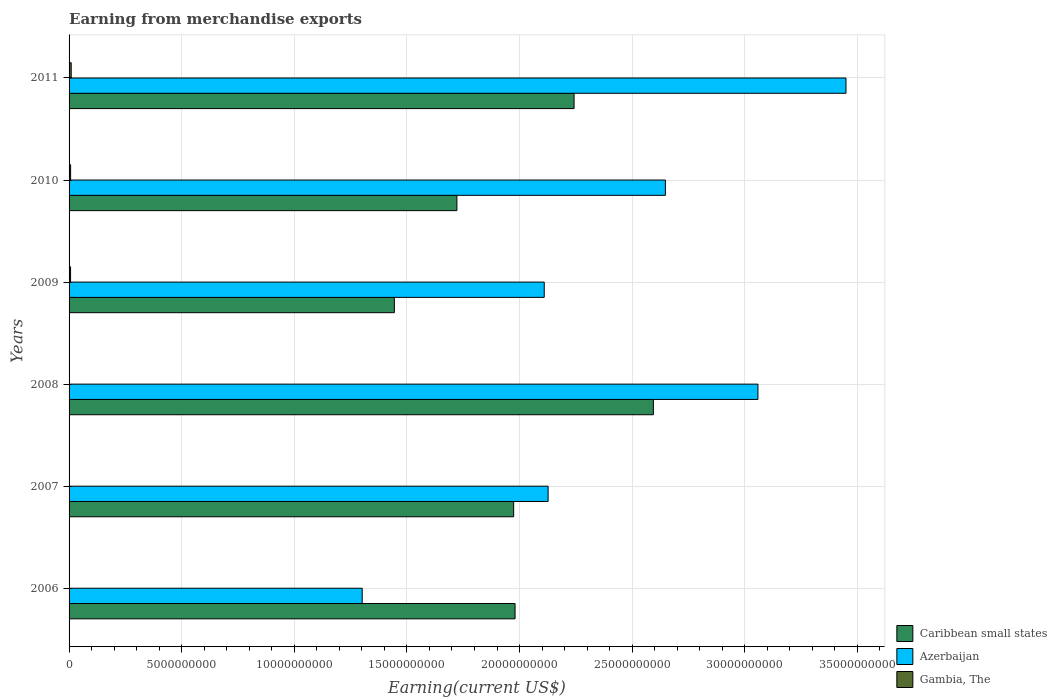How many different coloured bars are there?
Provide a succinct answer. 3. How many groups of bars are there?
Offer a terse response. 6. Are the number of bars on each tick of the Y-axis equal?
Provide a short and direct response. Yes. What is the amount earned from merchandise exports in Azerbaijan in 2010?
Offer a very short reply. 2.65e+1. Across all years, what is the maximum amount earned from merchandise exports in Gambia, The?
Provide a succinct answer. 9.49e+07. Across all years, what is the minimum amount earned from merchandise exports in Azerbaijan?
Offer a terse response. 1.30e+1. In which year was the amount earned from merchandise exports in Caribbean small states maximum?
Provide a short and direct response. 2008. What is the total amount earned from merchandise exports in Caribbean small states in the graph?
Keep it short and to the point. 1.20e+11. What is the difference between the amount earned from merchandise exports in Caribbean small states in 2008 and that in 2009?
Your answer should be compact. 1.15e+1. What is the difference between the amount earned from merchandise exports in Azerbaijan in 2009 and the amount earned from merchandise exports in Caribbean small states in 2011?
Make the answer very short. -1.33e+09. What is the average amount earned from merchandise exports in Caribbean small states per year?
Your response must be concise. 1.99e+1. In the year 2006, what is the difference between the amount earned from merchandise exports in Caribbean small states and amount earned from merchandise exports in Gambia, The?
Give a very brief answer. 1.98e+1. In how many years, is the amount earned from merchandise exports in Azerbaijan greater than 33000000000 US$?
Offer a very short reply. 1. What is the ratio of the amount earned from merchandise exports in Gambia, The in 2007 to that in 2011?
Your answer should be very brief. 0.14. Is the amount earned from merchandise exports in Gambia, The in 2007 less than that in 2009?
Give a very brief answer. Yes. Is the difference between the amount earned from merchandise exports in Caribbean small states in 2009 and 2011 greater than the difference between the amount earned from merchandise exports in Gambia, The in 2009 and 2011?
Keep it short and to the point. No. What is the difference between the highest and the second highest amount earned from merchandise exports in Azerbaijan?
Give a very brief answer. 3.91e+09. What is the difference between the highest and the lowest amount earned from merchandise exports in Caribbean small states?
Your answer should be very brief. 1.15e+1. In how many years, is the amount earned from merchandise exports in Azerbaijan greater than the average amount earned from merchandise exports in Azerbaijan taken over all years?
Offer a very short reply. 3. What does the 2nd bar from the top in 2006 represents?
Provide a short and direct response. Azerbaijan. What does the 3rd bar from the bottom in 2006 represents?
Provide a succinct answer. Gambia, The. Is it the case that in every year, the sum of the amount earned from merchandise exports in Azerbaijan and amount earned from merchandise exports in Gambia, The is greater than the amount earned from merchandise exports in Caribbean small states?
Keep it short and to the point. No. How many bars are there?
Ensure brevity in your answer.  18. Are all the bars in the graph horizontal?
Your answer should be compact. Yes. How many years are there in the graph?
Offer a very short reply. 6. Does the graph contain grids?
Keep it short and to the point. Yes. How many legend labels are there?
Offer a terse response. 3. How are the legend labels stacked?
Your answer should be very brief. Vertical. What is the title of the graph?
Your answer should be compact. Earning from merchandise exports. What is the label or title of the X-axis?
Ensure brevity in your answer.  Earning(current US$). What is the label or title of the Y-axis?
Your response must be concise. Years. What is the Earning(current US$) of Caribbean small states in 2006?
Your answer should be very brief. 1.98e+1. What is the Earning(current US$) in Azerbaijan in 2006?
Offer a terse response. 1.30e+1. What is the Earning(current US$) in Gambia, The in 2006?
Provide a succinct answer. 1.15e+07. What is the Earning(current US$) of Caribbean small states in 2007?
Offer a very short reply. 1.97e+1. What is the Earning(current US$) in Azerbaijan in 2007?
Your answer should be very brief. 2.13e+1. What is the Earning(current US$) of Gambia, The in 2007?
Your response must be concise. 1.33e+07. What is the Earning(current US$) of Caribbean small states in 2008?
Provide a succinct answer. 2.59e+1. What is the Earning(current US$) in Azerbaijan in 2008?
Provide a short and direct response. 3.06e+1. What is the Earning(current US$) in Gambia, The in 2008?
Provide a short and direct response. 1.37e+07. What is the Earning(current US$) of Caribbean small states in 2009?
Provide a succinct answer. 1.44e+1. What is the Earning(current US$) of Azerbaijan in 2009?
Your answer should be compact. 2.11e+1. What is the Earning(current US$) of Gambia, The in 2009?
Keep it short and to the point. 6.59e+07. What is the Earning(current US$) of Caribbean small states in 2010?
Make the answer very short. 1.72e+1. What is the Earning(current US$) of Azerbaijan in 2010?
Make the answer very short. 2.65e+1. What is the Earning(current US$) in Gambia, The in 2010?
Keep it short and to the point. 6.83e+07. What is the Earning(current US$) of Caribbean small states in 2011?
Keep it short and to the point. 2.24e+1. What is the Earning(current US$) in Azerbaijan in 2011?
Ensure brevity in your answer.  3.45e+1. What is the Earning(current US$) of Gambia, The in 2011?
Provide a succinct answer. 9.49e+07. Across all years, what is the maximum Earning(current US$) of Caribbean small states?
Provide a short and direct response. 2.59e+1. Across all years, what is the maximum Earning(current US$) in Azerbaijan?
Offer a very short reply. 3.45e+1. Across all years, what is the maximum Earning(current US$) of Gambia, The?
Your response must be concise. 9.49e+07. Across all years, what is the minimum Earning(current US$) of Caribbean small states?
Keep it short and to the point. 1.44e+1. Across all years, what is the minimum Earning(current US$) of Azerbaijan?
Make the answer very short. 1.30e+1. Across all years, what is the minimum Earning(current US$) in Gambia, The?
Offer a terse response. 1.15e+07. What is the total Earning(current US$) of Caribbean small states in the graph?
Provide a short and direct response. 1.20e+11. What is the total Earning(current US$) of Azerbaijan in the graph?
Ensure brevity in your answer.  1.47e+11. What is the total Earning(current US$) in Gambia, The in the graph?
Provide a short and direct response. 2.68e+08. What is the difference between the Earning(current US$) in Caribbean small states in 2006 and that in 2007?
Give a very brief answer. 6.19e+07. What is the difference between the Earning(current US$) of Azerbaijan in 2006 and that in 2007?
Make the answer very short. -8.25e+09. What is the difference between the Earning(current US$) in Gambia, The in 2006 and that in 2007?
Offer a very short reply. -1.87e+06. What is the difference between the Earning(current US$) of Caribbean small states in 2006 and that in 2008?
Your answer should be very brief. -6.14e+09. What is the difference between the Earning(current US$) of Azerbaijan in 2006 and that in 2008?
Ensure brevity in your answer.  -1.76e+1. What is the difference between the Earning(current US$) of Gambia, The in 2006 and that in 2008?
Keep it short and to the point. -2.21e+06. What is the difference between the Earning(current US$) of Caribbean small states in 2006 and that in 2009?
Provide a short and direct response. 5.36e+09. What is the difference between the Earning(current US$) in Azerbaijan in 2006 and that in 2009?
Provide a short and direct response. -8.08e+09. What is the difference between the Earning(current US$) of Gambia, The in 2006 and that in 2009?
Keep it short and to the point. -5.45e+07. What is the difference between the Earning(current US$) of Caribbean small states in 2006 and that in 2010?
Provide a succinct answer. 2.58e+09. What is the difference between the Earning(current US$) of Azerbaijan in 2006 and that in 2010?
Give a very brief answer. -1.35e+1. What is the difference between the Earning(current US$) of Gambia, The in 2006 and that in 2010?
Your answer should be very brief. -5.68e+07. What is the difference between the Earning(current US$) in Caribbean small states in 2006 and that in 2011?
Offer a terse response. -2.62e+09. What is the difference between the Earning(current US$) in Azerbaijan in 2006 and that in 2011?
Make the answer very short. -2.15e+1. What is the difference between the Earning(current US$) in Gambia, The in 2006 and that in 2011?
Ensure brevity in your answer.  -8.34e+07. What is the difference between the Earning(current US$) in Caribbean small states in 2007 and that in 2008?
Ensure brevity in your answer.  -6.20e+09. What is the difference between the Earning(current US$) of Azerbaijan in 2007 and that in 2008?
Offer a very short reply. -9.32e+09. What is the difference between the Earning(current US$) in Gambia, The in 2007 and that in 2008?
Your answer should be very brief. -3.33e+05. What is the difference between the Earning(current US$) in Caribbean small states in 2007 and that in 2009?
Offer a very short reply. 5.30e+09. What is the difference between the Earning(current US$) in Azerbaijan in 2007 and that in 2009?
Provide a succinct answer. 1.72e+08. What is the difference between the Earning(current US$) of Gambia, The in 2007 and that in 2009?
Provide a short and direct response. -5.26e+07. What is the difference between the Earning(current US$) in Caribbean small states in 2007 and that in 2010?
Make the answer very short. 2.52e+09. What is the difference between the Earning(current US$) of Azerbaijan in 2007 and that in 2010?
Your answer should be compact. -5.21e+09. What is the difference between the Earning(current US$) in Gambia, The in 2007 and that in 2010?
Offer a terse response. -5.50e+07. What is the difference between the Earning(current US$) in Caribbean small states in 2007 and that in 2011?
Ensure brevity in your answer.  -2.68e+09. What is the difference between the Earning(current US$) of Azerbaijan in 2007 and that in 2011?
Make the answer very short. -1.32e+1. What is the difference between the Earning(current US$) in Gambia, The in 2007 and that in 2011?
Your response must be concise. -8.16e+07. What is the difference between the Earning(current US$) of Caribbean small states in 2008 and that in 2009?
Offer a very short reply. 1.15e+1. What is the difference between the Earning(current US$) of Azerbaijan in 2008 and that in 2009?
Provide a short and direct response. 9.49e+09. What is the difference between the Earning(current US$) in Gambia, The in 2008 and that in 2009?
Your answer should be compact. -5.22e+07. What is the difference between the Earning(current US$) of Caribbean small states in 2008 and that in 2010?
Your answer should be very brief. 8.72e+09. What is the difference between the Earning(current US$) in Azerbaijan in 2008 and that in 2010?
Your response must be concise. 4.11e+09. What is the difference between the Earning(current US$) of Gambia, The in 2008 and that in 2010?
Ensure brevity in your answer.  -5.46e+07. What is the difference between the Earning(current US$) of Caribbean small states in 2008 and that in 2011?
Provide a succinct answer. 3.52e+09. What is the difference between the Earning(current US$) in Azerbaijan in 2008 and that in 2011?
Your response must be concise. -3.91e+09. What is the difference between the Earning(current US$) in Gambia, The in 2008 and that in 2011?
Offer a very short reply. -8.12e+07. What is the difference between the Earning(current US$) in Caribbean small states in 2009 and that in 2010?
Offer a very short reply. -2.78e+09. What is the difference between the Earning(current US$) in Azerbaijan in 2009 and that in 2010?
Make the answer very short. -5.38e+09. What is the difference between the Earning(current US$) of Gambia, The in 2009 and that in 2010?
Offer a terse response. -2.37e+06. What is the difference between the Earning(current US$) of Caribbean small states in 2009 and that in 2011?
Your answer should be very brief. -7.98e+09. What is the difference between the Earning(current US$) of Azerbaijan in 2009 and that in 2011?
Your answer should be very brief. -1.34e+1. What is the difference between the Earning(current US$) in Gambia, The in 2009 and that in 2011?
Make the answer very short. -2.90e+07. What is the difference between the Earning(current US$) of Caribbean small states in 2010 and that in 2011?
Keep it short and to the point. -5.20e+09. What is the difference between the Earning(current US$) in Azerbaijan in 2010 and that in 2011?
Ensure brevity in your answer.  -8.02e+09. What is the difference between the Earning(current US$) of Gambia, The in 2010 and that in 2011?
Offer a terse response. -2.66e+07. What is the difference between the Earning(current US$) in Caribbean small states in 2006 and the Earning(current US$) in Azerbaijan in 2007?
Your answer should be very brief. -1.47e+09. What is the difference between the Earning(current US$) in Caribbean small states in 2006 and the Earning(current US$) in Gambia, The in 2007?
Your answer should be compact. 1.98e+1. What is the difference between the Earning(current US$) in Azerbaijan in 2006 and the Earning(current US$) in Gambia, The in 2007?
Your answer should be very brief. 1.30e+1. What is the difference between the Earning(current US$) of Caribbean small states in 2006 and the Earning(current US$) of Azerbaijan in 2008?
Offer a very short reply. -1.08e+1. What is the difference between the Earning(current US$) in Caribbean small states in 2006 and the Earning(current US$) in Gambia, The in 2008?
Offer a very short reply. 1.98e+1. What is the difference between the Earning(current US$) of Azerbaijan in 2006 and the Earning(current US$) of Gambia, The in 2008?
Give a very brief answer. 1.30e+1. What is the difference between the Earning(current US$) in Caribbean small states in 2006 and the Earning(current US$) in Azerbaijan in 2009?
Give a very brief answer. -1.30e+09. What is the difference between the Earning(current US$) in Caribbean small states in 2006 and the Earning(current US$) in Gambia, The in 2009?
Keep it short and to the point. 1.97e+1. What is the difference between the Earning(current US$) of Azerbaijan in 2006 and the Earning(current US$) of Gambia, The in 2009?
Offer a terse response. 1.29e+1. What is the difference between the Earning(current US$) in Caribbean small states in 2006 and the Earning(current US$) in Azerbaijan in 2010?
Your answer should be compact. -6.67e+09. What is the difference between the Earning(current US$) in Caribbean small states in 2006 and the Earning(current US$) in Gambia, The in 2010?
Provide a short and direct response. 1.97e+1. What is the difference between the Earning(current US$) of Azerbaijan in 2006 and the Earning(current US$) of Gambia, The in 2010?
Give a very brief answer. 1.29e+1. What is the difference between the Earning(current US$) in Caribbean small states in 2006 and the Earning(current US$) in Azerbaijan in 2011?
Your answer should be very brief. -1.47e+1. What is the difference between the Earning(current US$) of Caribbean small states in 2006 and the Earning(current US$) of Gambia, The in 2011?
Your response must be concise. 1.97e+1. What is the difference between the Earning(current US$) of Azerbaijan in 2006 and the Earning(current US$) of Gambia, The in 2011?
Your response must be concise. 1.29e+1. What is the difference between the Earning(current US$) of Caribbean small states in 2007 and the Earning(current US$) of Azerbaijan in 2008?
Your answer should be very brief. -1.08e+1. What is the difference between the Earning(current US$) of Caribbean small states in 2007 and the Earning(current US$) of Gambia, The in 2008?
Give a very brief answer. 1.97e+1. What is the difference between the Earning(current US$) of Azerbaijan in 2007 and the Earning(current US$) of Gambia, The in 2008?
Your response must be concise. 2.13e+1. What is the difference between the Earning(current US$) of Caribbean small states in 2007 and the Earning(current US$) of Azerbaijan in 2009?
Provide a succinct answer. -1.36e+09. What is the difference between the Earning(current US$) of Caribbean small states in 2007 and the Earning(current US$) of Gambia, The in 2009?
Your answer should be very brief. 1.97e+1. What is the difference between the Earning(current US$) in Azerbaijan in 2007 and the Earning(current US$) in Gambia, The in 2009?
Provide a short and direct response. 2.12e+1. What is the difference between the Earning(current US$) of Caribbean small states in 2007 and the Earning(current US$) of Azerbaijan in 2010?
Your answer should be compact. -6.74e+09. What is the difference between the Earning(current US$) in Caribbean small states in 2007 and the Earning(current US$) in Gambia, The in 2010?
Provide a succinct answer. 1.97e+1. What is the difference between the Earning(current US$) of Azerbaijan in 2007 and the Earning(current US$) of Gambia, The in 2010?
Make the answer very short. 2.12e+1. What is the difference between the Earning(current US$) of Caribbean small states in 2007 and the Earning(current US$) of Azerbaijan in 2011?
Your response must be concise. -1.48e+1. What is the difference between the Earning(current US$) of Caribbean small states in 2007 and the Earning(current US$) of Gambia, The in 2011?
Your response must be concise. 1.96e+1. What is the difference between the Earning(current US$) of Azerbaijan in 2007 and the Earning(current US$) of Gambia, The in 2011?
Make the answer very short. 2.12e+1. What is the difference between the Earning(current US$) of Caribbean small states in 2008 and the Earning(current US$) of Azerbaijan in 2009?
Offer a terse response. 4.85e+09. What is the difference between the Earning(current US$) in Caribbean small states in 2008 and the Earning(current US$) in Gambia, The in 2009?
Your answer should be compact. 2.59e+1. What is the difference between the Earning(current US$) in Azerbaijan in 2008 and the Earning(current US$) in Gambia, The in 2009?
Your answer should be compact. 3.05e+1. What is the difference between the Earning(current US$) of Caribbean small states in 2008 and the Earning(current US$) of Azerbaijan in 2010?
Keep it short and to the point. -5.33e+08. What is the difference between the Earning(current US$) of Caribbean small states in 2008 and the Earning(current US$) of Gambia, The in 2010?
Your response must be concise. 2.59e+1. What is the difference between the Earning(current US$) of Azerbaijan in 2008 and the Earning(current US$) of Gambia, The in 2010?
Provide a short and direct response. 3.05e+1. What is the difference between the Earning(current US$) in Caribbean small states in 2008 and the Earning(current US$) in Azerbaijan in 2011?
Your answer should be very brief. -8.55e+09. What is the difference between the Earning(current US$) of Caribbean small states in 2008 and the Earning(current US$) of Gambia, The in 2011?
Give a very brief answer. 2.58e+1. What is the difference between the Earning(current US$) in Azerbaijan in 2008 and the Earning(current US$) in Gambia, The in 2011?
Keep it short and to the point. 3.05e+1. What is the difference between the Earning(current US$) of Caribbean small states in 2009 and the Earning(current US$) of Azerbaijan in 2010?
Make the answer very short. -1.20e+1. What is the difference between the Earning(current US$) in Caribbean small states in 2009 and the Earning(current US$) in Gambia, The in 2010?
Offer a terse response. 1.44e+1. What is the difference between the Earning(current US$) in Azerbaijan in 2009 and the Earning(current US$) in Gambia, The in 2010?
Give a very brief answer. 2.10e+1. What is the difference between the Earning(current US$) of Caribbean small states in 2009 and the Earning(current US$) of Azerbaijan in 2011?
Your answer should be compact. -2.01e+1. What is the difference between the Earning(current US$) in Caribbean small states in 2009 and the Earning(current US$) in Gambia, The in 2011?
Your response must be concise. 1.43e+1. What is the difference between the Earning(current US$) in Azerbaijan in 2009 and the Earning(current US$) in Gambia, The in 2011?
Keep it short and to the point. 2.10e+1. What is the difference between the Earning(current US$) of Caribbean small states in 2010 and the Earning(current US$) of Azerbaijan in 2011?
Give a very brief answer. -1.73e+1. What is the difference between the Earning(current US$) of Caribbean small states in 2010 and the Earning(current US$) of Gambia, The in 2011?
Your answer should be compact. 1.71e+1. What is the difference between the Earning(current US$) of Azerbaijan in 2010 and the Earning(current US$) of Gambia, The in 2011?
Offer a terse response. 2.64e+1. What is the average Earning(current US$) in Caribbean small states per year?
Your answer should be compact. 1.99e+1. What is the average Earning(current US$) of Azerbaijan per year?
Make the answer very short. 2.45e+1. What is the average Earning(current US$) of Gambia, The per year?
Make the answer very short. 4.46e+07. In the year 2006, what is the difference between the Earning(current US$) of Caribbean small states and Earning(current US$) of Azerbaijan?
Your answer should be very brief. 6.79e+09. In the year 2006, what is the difference between the Earning(current US$) in Caribbean small states and Earning(current US$) in Gambia, The?
Offer a terse response. 1.98e+1. In the year 2006, what is the difference between the Earning(current US$) of Azerbaijan and Earning(current US$) of Gambia, The?
Provide a succinct answer. 1.30e+1. In the year 2007, what is the difference between the Earning(current US$) in Caribbean small states and Earning(current US$) in Azerbaijan?
Offer a terse response. -1.53e+09. In the year 2007, what is the difference between the Earning(current US$) of Caribbean small states and Earning(current US$) of Gambia, The?
Make the answer very short. 1.97e+1. In the year 2007, what is the difference between the Earning(current US$) of Azerbaijan and Earning(current US$) of Gambia, The?
Offer a very short reply. 2.13e+1. In the year 2008, what is the difference between the Earning(current US$) in Caribbean small states and Earning(current US$) in Azerbaijan?
Provide a succinct answer. -4.64e+09. In the year 2008, what is the difference between the Earning(current US$) in Caribbean small states and Earning(current US$) in Gambia, The?
Your response must be concise. 2.59e+1. In the year 2008, what is the difference between the Earning(current US$) of Azerbaijan and Earning(current US$) of Gambia, The?
Provide a succinct answer. 3.06e+1. In the year 2009, what is the difference between the Earning(current US$) of Caribbean small states and Earning(current US$) of Azerbaijan?
Offer a terse response. -6.65e+09. In the year 2009, what is the difference between the Earning(current US$) of Caribbean small states and Earning(current US$) of Gambia, The?
Offer a very short reply. 1.44e+1. In the year 2009, what is the difference between the Earning(current US$) in Azerbaijan and Earning(current US$) in Gambia, The?
Keep it short and to the point. 2.10e+1. In the year 2010, what is the difference between the Earning(current US$) of Caribbean small states and Earning(current US$) of Azerbaijan?
Provide a succinct answer. -9.26e+09. In the year 2010, what is the difference between the Earning(current US$) in Caribbean small states and Earning(current US$) in Gambia, The?
Your answer should be very brief. 1.72e+1. In the year 2010, what is the difference between the Earning(current US$) of Azerbaijan and Earning(current US$) of Gambia, The?
Offer a terse response. 2.64e+1. In the year 2011, what is the difference between the Earning(current US$) of Caribbean small states and Earning(current US$) of Azerbaijan?
Provide a short and direct response. -1.21e+1. In the year 2011, what is the difference between the Earning(current US$) in Caribbean small states and Earning(current US$) in Gambia, The?
Provide a succinct answer. 2.23e+1. In the year 2011, what is the difference between the Earning(current US$) in Azerbaijan and Earning(current US$) in Gambia, The?
Make the answer very short. 3.44e+1. What is the ratio of the Earning(current US$) of Caribbean small states in 2006 to that in 2007?
Your answer should be very brief. 1. What is the ratio of the Earning(current US$) in Azerbaijan in 2006 to that in 2007?
Your answer should be very brief. 0.61. What is the ratio of the Earning(current US$) in Gambia, The in 2006 to that in 2007?
Keep it short and to the point. 0.86. What is the ratio of the Earning(current US$) in Caribbean small states in 2006 to that in 2008?
Your response must be concise. 0.76. What is the ratio of the Earning(current US$) in Azerbaijan in 2006 to that in 2008?
Provide a short and direct response. 0.43. What is the ratio of the Earning(current US$) of Gambia, The in 2006 to that in 2008?
Your response must be concise. 0.84. What is the ratio of the Earning(current US$) of Caribbean small states in 2006 to that in 2009?
Offer a very short reply. 1.37. What is the ratio of the Earning(current US$) in Azerbaijan in 2006 to that in 2009?
Ensure brevity in your answer.  0.62. What is the ratio of the Earning(current US$) in Gambia, The in 2006 to that in 2009?
Your answer should be compact. 0.17. What is the ratio of the Earning(current US$) of Caribbean small states in 2006 to that in 2010?
Provide a short and direct response. 1.15. What is the ratio of the Earning(current US$) in Azerbaijan in 2006 to that in 2010?
Keep it short and to the point. 0.49. What is the ratio of the Earning(current US$) of Gambia, The in 2006 to that in 2010?
Keep it short and to the point. 0.17. What is the ratio of the Earning(current US$) in Caribbean small states in 2006 to that in 2011?
Your response must be concise. 0.88. What is the ratio of the Earning(current US$) in Azerbaijan in 2006 to that in 2011?
Offer a very short reply. 0.38. What is the ratio of the Earning(current US$) in Gambia, The in 2006 to that in 2011?
Your response must be concise. 0.12. What is the ratio of the Earning(current US$) of Caribbean small states in 2007 to that in 2008?
Keep it short and to the point. 0.76. What is the ratio of the Earning(current US$) in Azerbaijan in 2007 to that in 2008?
Provide a succinct answer. 0.7. What is the ratio of the Earning(current US$) of Gambia, The in 2007 to that in 2008?
Your response must be concise. 0.98. What is the ratio of the Earning(current US$) of Caribbean small states in 2007 to that in 2009?
Provide a short and direct response. 1.37. What is the ratio of the Earning(current US$) in Azerbaijan in 2007 to that in 2009?
Keep it short and to the point. 1.01. What is the ratio of the Earning(current US$) in Gambia, The in 2007 to that in 2009?
Give a very brief answer. 0.2. What is the ratio of the Earning(current US$) in Caribbean small states in 2007 to that in 2010?
Give a very brief answer. 1.15. What is the ratio of the Earning(current US$) of Azerbaijan in 2007 to that in 2010?
Keep it short and to the point. 0.8. What is the ratio of the Earning(current US$) of Gambia, The in 2007 to that in 2010?
Ensure brevity in your answer.  0.2. What is the ratio of the Earning(current US$) in Caribbean small states in 2007 to that in 2011?
Make the answer very short. 0.88. What is the ratio of the Earning(current US$) of Azerbaijan in 2007 to that in 2011?
Your answer should be very brief. 0.62. What is the ratio of the Earning(current US$) in Gambia, The in 2007 to that in 2011?
Provide a short and direct response. 0.14. What is the ratio of the Earning(current US$) in Caribbean small states in 2008 to that in 2009?
Offer a terse response. 1.8. What is the ratio of the Earning(current US$) in Azerbaijan in 2008 to that in 2009?
Offer a terse response. 1.45. What is the ratio of the Earning(current US$) in Gambia, The in 2008 to that in 2009?
Give a very brief answer. 0.21. What is the ratio of the Earning(current US$) in Caribbean small states in 2008 to that in 2010?
Your response must be concise. 1.51. What is the ratio of the Earning(current US$) in Azerbaijan in 2008 to that in 2010?
Ensure brevity in your answer.  1.16. What is the ratio of the Earning(current US$) in Gambia, The in 2008 to that in 2010?
Your answer should be compact. 0.2. What is the ratio of the Earning(current US$) in Caribbean small states in 2008 to that in 2011?
Your answer should be very brief. 1.16. What is the ratio of the Earning(current US$) of Azerbaijan in 2008 to that in 2011?
Offer a terse response. 0.89. What is the ratio of the Earning(current US$) in Gambia, The in 2008 to that in 2011?
Make the answer very short. 0.14. What is the ratio of the Earning(current US$) of Caribbean small states in 2009 to that in 2010?
Offer a terse response. 0.84. What is the ratio of the Earning(current US$) in Azerbaijan in 2009 to that in 2010?
Provide a short and direct response. 0.8. What is the ratio of the Earning(current US$) of Gambia, The in 2009 to that in 2010?
Give a very brief answer. 0.97. What is the ratio of the Earning(current US$) of Caribbean small states in 2009 to that in 2011?
Your answer should be very brief. 0.64. What is the ratio of the Earning(current US$) in Azerbaijan in 2009 to that in 2011?
Your response must be concise. 0.61. What is the ratio of the Earning(current US$) in Gambia, The in 2009 to that in 2011?
Provide a succinct answer. 0.69. What is the ratio of the Earning(current US$) of Caribbean small states in 2010 to that in 2011?
Provide a succinct answer. 0.77. What is the ratio of the Earning(current US$) in Azerbaijan in 2010 to that in 2011?
Offer a terse response. 0.77. What is the ratio of the Earning(current US$) of Gambia, The in 2010 to that in 2011?
Make the answer very short. 0.72. What is the difference between the highest and the second highest Earning(current US$) of Caribbean small states?
Make the answer very short. 3.52e+09. What is the difference between the highest and the second highest Earning(current US$) in Azerbaijan?
Your response must be concise. 3.91e+09. What is the difference between the highest and the second highest Earning(current US$) of Gambia, The?
Give a very brief answer. 2.66e+07. What is the difference between the highest and the lowest Earning(current US$) in Caribbean small states?
Ensure brevity in your answer.  1.15e+1. What is the difference between the highest and the lowest Earning(current US$) of Azerbaijan?
Give a very brief answer. 2.15e+1. What is the difference between the highest and the lowest Earning(current US$) in Gambia, The?
Provide a succinct answer. 8.34e+07. 